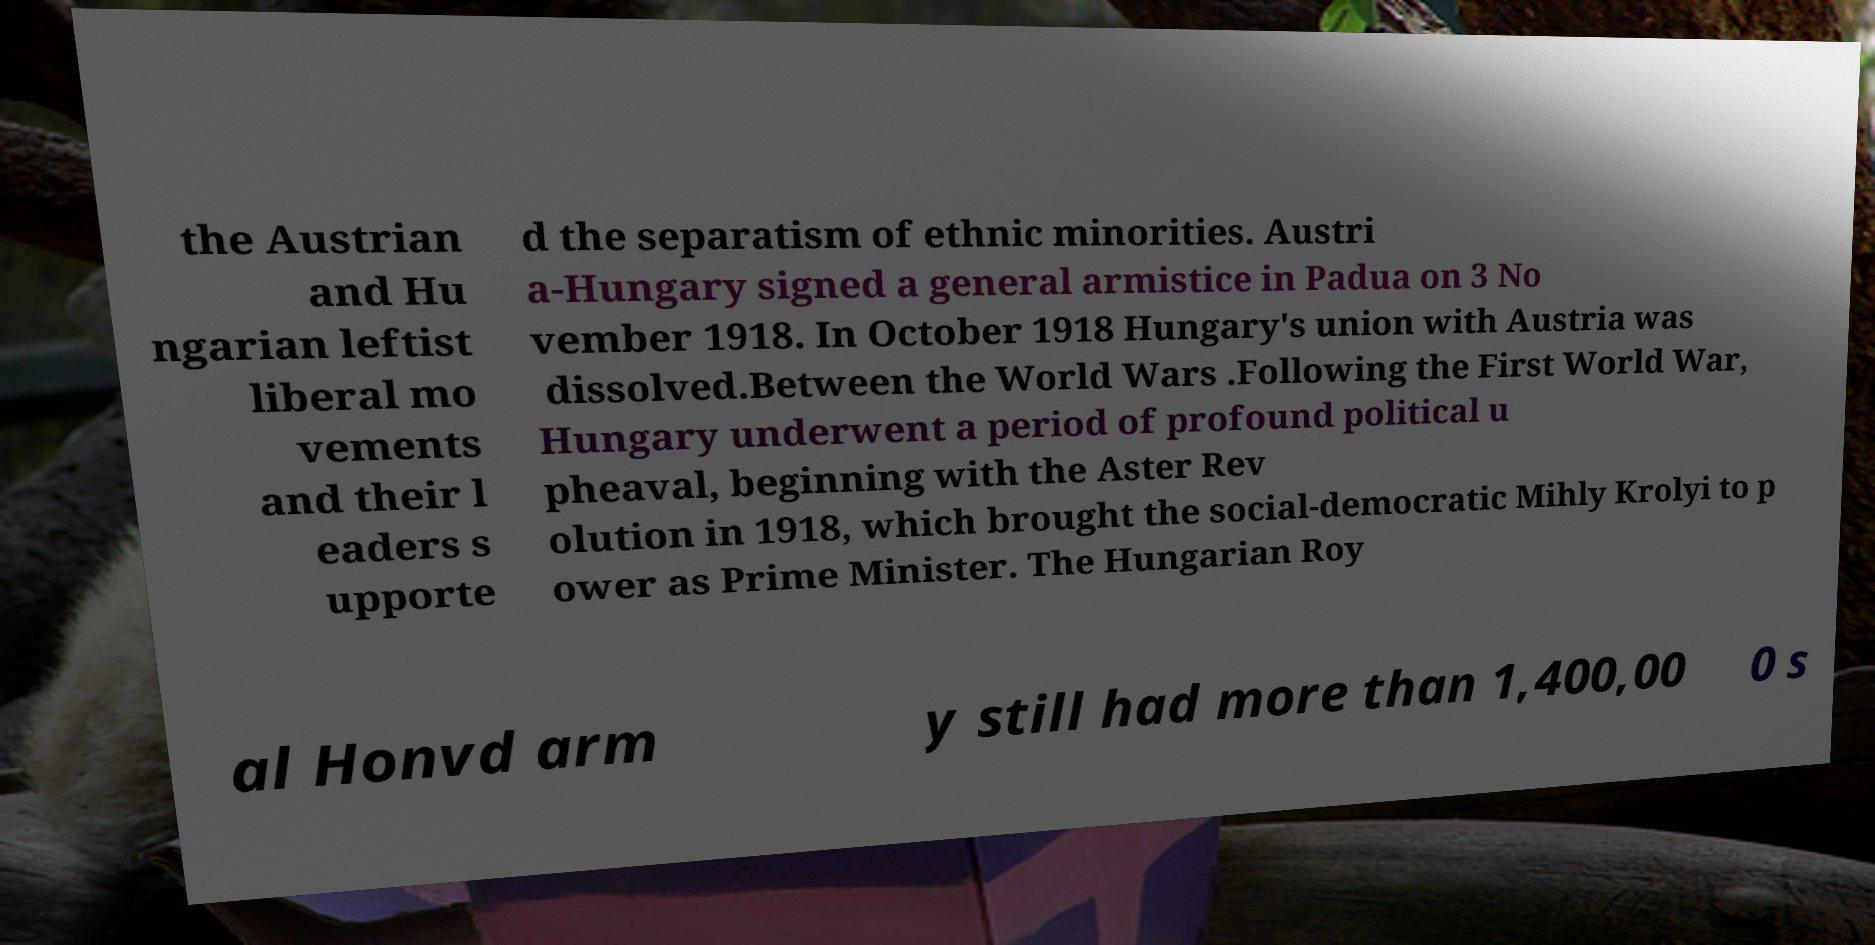Can you read and provide the text displayed in the image?This photo seems to have some interesting text. Can you extract and type it out for me? the Austrian and Hu ngarian leftist liberal mo vements and their l eaders s upporte d the separatism of ethnic minorities. Austri a-Hungary signed a general armistice in Padua on 3 No vember 1918. In October 1918 Hungary's union with Austria was dissolved.Between the World Wars .Following the First World War, Hungary underwent a period of profound political u pheaval, beginning with the Aster Rev olution in 1918, which brought the social-democratic Mihly Krolyi to p ower as Prime Minister. The Hungarian Roy al Honvd arm y still had more than 1,400,00 0 s 